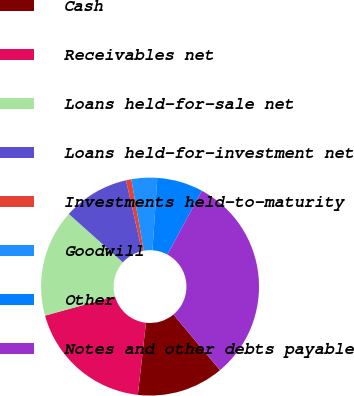<chart> <loc_0><loc_0><loc_500><loc_500><pie_chart><fcel>Cash<fcel>Receivables net<fcel>Loans held-for-sale net<fcel>Loans held-for-investment net<fcel>Investments held-to-maturity<fcel>Goodwill<fcel>Other<fcel>Notes and other debts payable<nl><fcel>12.88%<fcel>18.92%<fcel>15.9%<fcel>9.85%<fcel>0.79%<fcel>3.81%<fcel>6.83%<fcel>31.02%<nl></chart> 